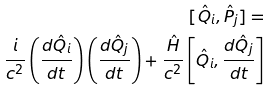Convert formula to latex. <formula><loc_0><loc_0><loc_500><loc_500>[ \hat { Q } _ { i } , \hat { P } _ { j } ] = \\ \frac { i { } } { c ^ { 2 } } \left ( \frac { d \hat { Q } _ { i } } { d t } \right ) \left ( \frac { d \hat { Q } _ { j } } { d t } \right ) + \frac { \hat { H } } { c ^ { 2 } } \left [ \hat { Q } _ { i } , \frac { d \hat { Q } _ { j } } { d t } \right ]</formula> 